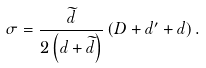<formula> <loc_0><loc_0><loc_500><loc_500>\sigma = \frac { \widetilde { d } } { 2 \left ( d + \widetilde { d } \right ) } \left ( D + d ^ { \prime } + d \right ) .</formula> 